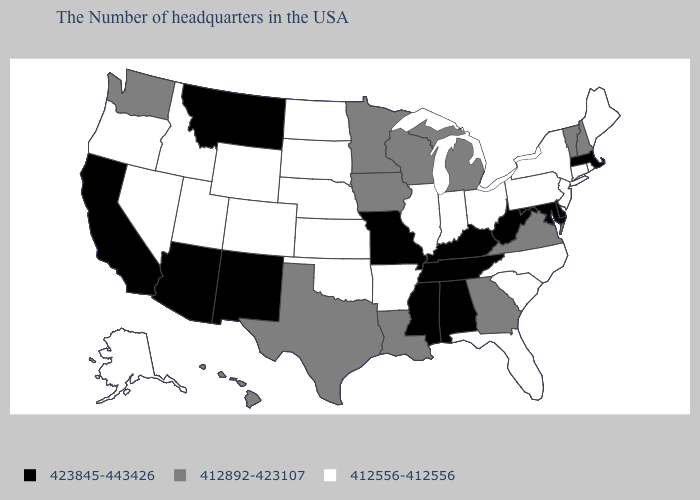What is the value of Wisconsin?
Be succinct. 412892-423107. Does New Jersey have the lowest value in the Northeast?
Short answer required. Yes. What is the value of North Carolina?
Answer briefly. 412556-412556. What is the highest value in the USA?
Short answer required. 423845-443426. What is the value of Washington?
Concise answer only. 412892-423107. Is the legend a continuous bar?
Short answer required. No. Name the states that have a value in the range 412556-412556?
Keep it brief. Maine, Rhode Island, Connecticut, New York, New Jersey, Pennsylvania, North Carolina, South Carolina, Ohio, Florida, Indiana, Illinois, Arkansas, Kansas, Nebraska, Oklahoma, South Dakota, North Dakota, Wyoming, Colorado, Utah, Idaho, Nevada, Oregon, Alaska. Is the legend a continuous bar?
Concise answer only. No. Which states hav the highest value in the West?
Quick response, please. New Mexico, Montana, Arizona, California. What is the lowest value in the Northeast?
Keep it brief. 412556-412556. Name the states that have a value in the range 423845-443426?
Keep it brief. Massachusetts, Delaware, Maryland, West Virginia, Kentucky, Alabama, Tennessee, Mississippi, Missouri, New Mexico, Montana, Arizona, California. Does Iowa have the same value as New Jersey?
Quick response, please. No. Does Maine have the highest value in the USA?
Concise answer only. No. Is the legend a continuous bar?
Keep it brief. No. 